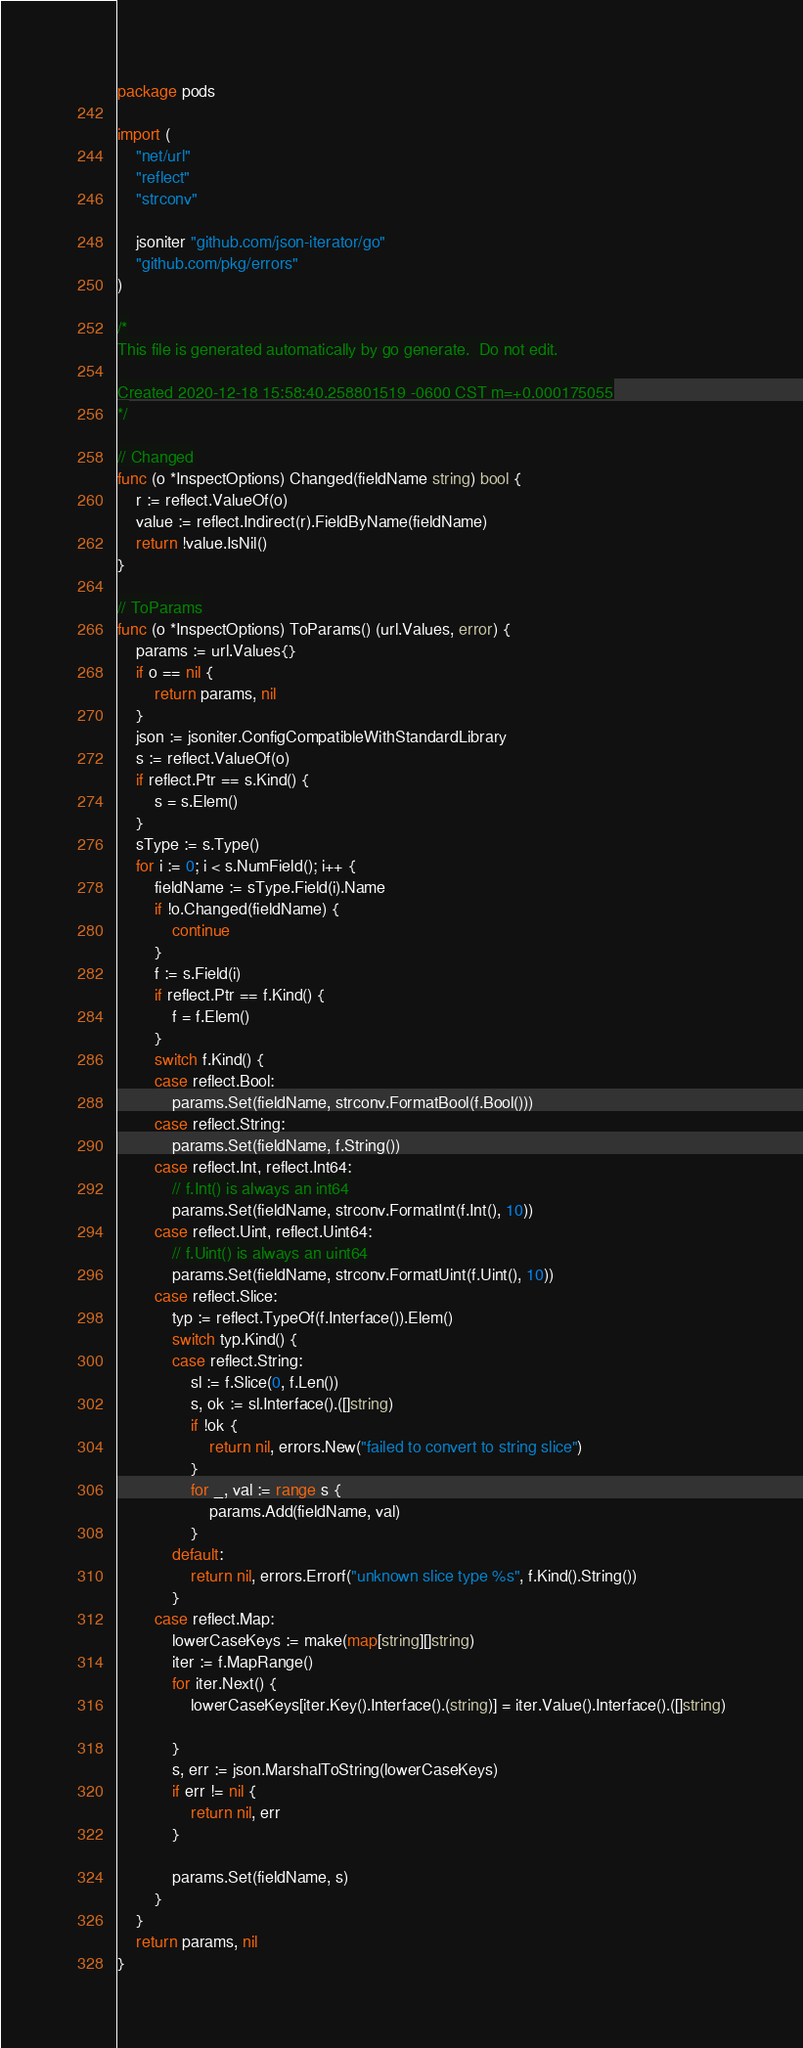<code> <loc_0><loc_0><loc_500><loc_500><_Go_>package pods

import (
	"net/url"
	"reflect"
	"strconv"

	jsoniter "github.com/json-iterator/go"
	"github.com/pkg/errors"
)

/*
This file is generated automatically by go generate.  Do not edit.

Created 2020-12-18 15:58:40.258801519 -0600 CST m=+0.000175055
*/

// Changed
func (o *InspectOptions) Changed(fieldName string) bool {
	r := reflect.ValueOf(o)
	value := reflect.Indirect(r).FieldByName(fieldName)
	return !value.IsNil()
}

// ToParams
func (o *InspectOptions) ToParams() (url.Values, error) {
	params := url.Values{}
	if o == nil {
		return params, nil
	}
	json := jsoniter.ConfigCompatibleWithStandardLibrary
	s := reflect.ValueOf(o)
	if reflect.Ptr == s.Kind() {
		s = s.Elem()
	}
	sType := s.Type()
	for i := 0; i < s.NumField(); i++ {
		fieldName := sType.Field(i).Name
		if !o.Changed(fieldName) {
			continue
		}
		f := s.Field(i)
		if reflect.Ptr == f.Kind() {
			f = f.Elem()
		}
		switch f.Kind() {
		case reflect.Bool:
			params.Set(fieldName, strconv.FormatBool(f.Bool()))
		case reflect.String:
			params.Set(fieldName, f.String())
		case reflect.Int, reflect.Int64:
			// f.Int() is always an int64
			params.Set(fieldName, strconv.FormatInt(f.Int(), 10))
		case reflect.Uint, reflect.Uint64:
			// f.Uint() is always an uint64
			params.Set(fieldName, strconv.FormatUint(f.Uint(), 10))
		case reflect.Slice:
			typ := reflect.TypeOf(f.Interface()).Elem()
			switch typ.Kind() {
			case reflect.String:
				sl := f.Slice(0, f.Len())
				s, ok := sl.Interface().([]string)
				if !ok {
					return nil, errors.New("failed to convert to string slice")
				}
				for _, val := range s {
					params.Add(fieldName, val)
				}
			default:
				return nil, errors.Errorf("unknown slice type %s", f.Kind().String())
			}
		case reflect.Map:
			lowerCaseKeys := make(map[string][]string)
			iter := f.MapRange()
			for iter.Next() {
				lowerCaseKeys[iter.Key().Interface().(string)] = iter.Value().Interface().([]string)

			}
			s, err := json.MarshalToString(lowerCaseKeys)
			if err != nil {
				return nil, err
			}

			params.Set(fieldName, s)
		}
	}
	return params, nil
}
</code> 